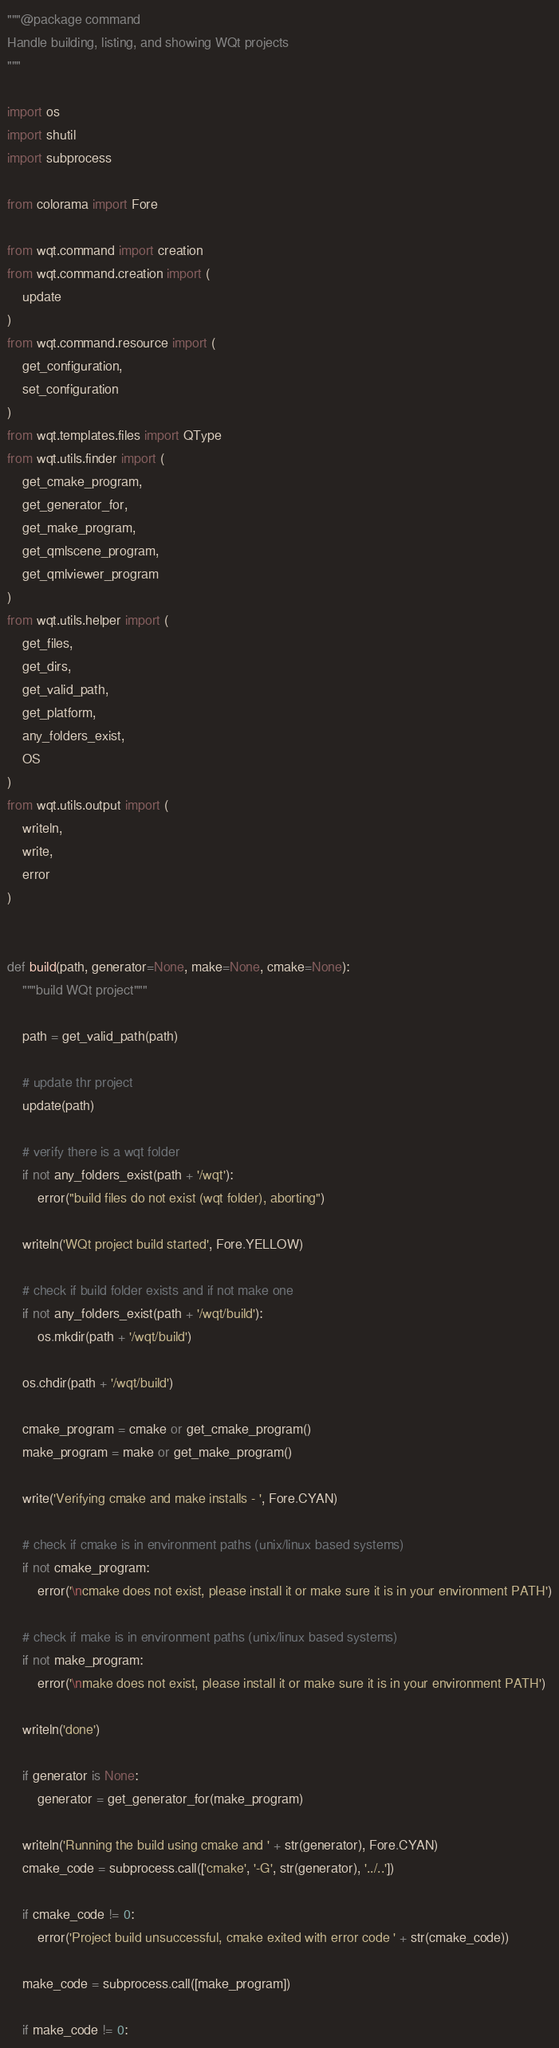<code> <loc_0><loc_0><loc_500><loc_500><_Python_>"""@package command
Handle building, listing, and showing WQt projects
"""

import os
import shutil
import subprocess

from colorama import Fore

from wqt.command import creation
from wqt.command.creation import (
    update
)
from wqt.command.resource import (
    get_configuration,
    set_configuration
)
from wqt.templates.files import QType
from wqt.utils.finder import (
    get_cmake_program,
    get_generator_for,
    get_make_program,
    get_qmlscene_program,
    get_qmlviewer_program
)
from wqt.utils.helper import (
    get_files,
    get_dirs,
    get_valid_path,
    get_platform,
    any_folders_exist,
    OS
)
from wqt.utils.output import (
    writeln,
    write,
    error
)


def build(path, generator=None, make=None, cmake=None):
    """build WQt project"""

    path = get_valid_path(path)

    # update thr project
    update(path)

    # verify there is a wqt folder
    if not any_folders_exist(path + '/wqt'):
        error("build files do not exist (wqt folder), aborting")

    writeln('WQt project build started', Fore.YELLOW)

    # check if build folder exists and if not make one
    if not any_folders_exist(path + '/wqt/build'):
        os.mkdir(path + '/wqt/build')

    os.chdir(path + '/wqt/build')

    cmake_program = cmake or get_cmake_program()
    make_program = make or get_make_program()

    write('Verifying cmake and make installs - ', Fore.CYAN)

    # check if cmake is in environment paths (unix/linux based systems)
    if not cmake_program:
        error('\ncmake does not exist, please install it or make sure it is in your environment PATH')

    # check if make is in environment paths (unix/linux based systems)
    if not make_program:
        error('\nmake does not exist, please install it or make sure it is in your environment PATH')

    writeln('done')

    if generator is None:
        generator = get_generator_for(make_program)

    writeln('Running the build using cmake and ' + str(generator), Fore.CYAN)
    cmake_code = subprocess.call(['cmake', '-G', str(generator), '../..'])

    if cmake_code != 0:
        error('Project build unsuccessful, cmake exited with error code ' + str(cmake_code))

    make_code = subprocess.call([make_program])

    if make_code != 0:</code> 